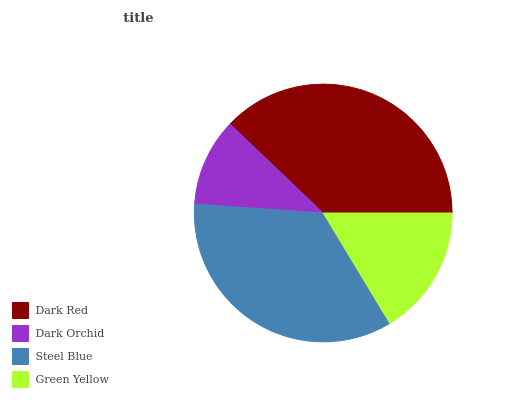Is Dark Orchid the minimum?
Answer yes or no. Yes. Is Dark Red the maximum?
Answer yes or no. Yes. Is Steel Blue the minimum?
Answer yes or no. No. Is Steel Blue the maximum?
Answer yes or no. No. Is Steel Blue greater than Dark Orchid?
Answer yes or no. Yes. Is Dark Orchid less than Steel Blue?
Answer yes or no. Yes. Is Dark Orchid greater than Steel Blue?
Answer yes or no. No. Is Steel Blue less than Dark Orchid?
Answer yes or no. No. Is Steel Blue the high median?
Answer yes or no. Yes. Is Green Yellow the low median?
Answer yes or no. Yes. Is Dark Orchid the high median?
Answer yes or no. No. Is Dark Red the low median?
Answer yes or no. No. 